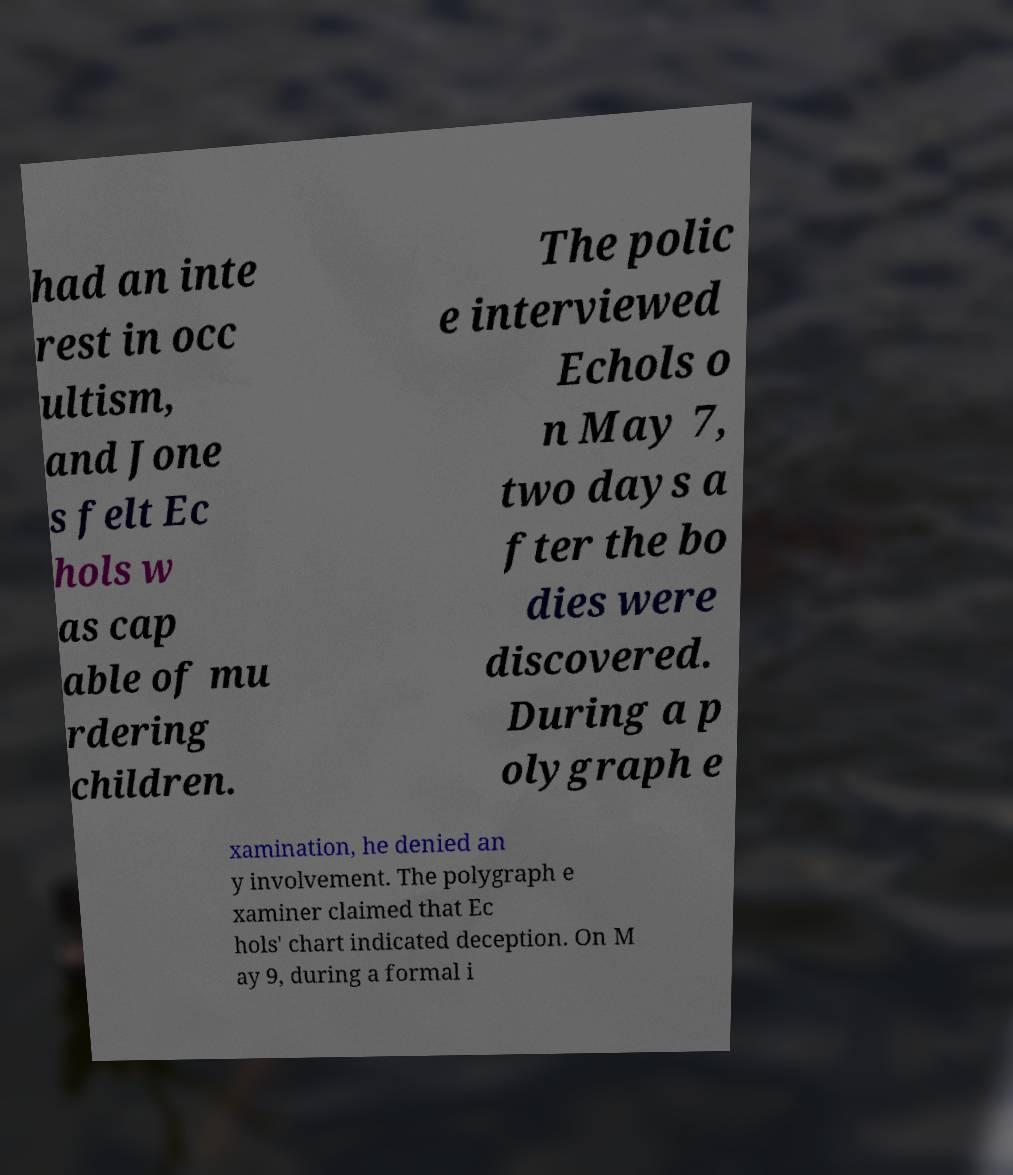Can you accurately transcribe the text from the provided image for me? had an inte rest in occ ultism, and Jone s felt Ec hols w as cap able of mu rdering children. The polic e interviewed Echols o n May 7, two days a fter the bo dies were discovered. During a p olygraph e xamination, he denied an y involvement. The polygraph e xaminer claimed that Ec hols' chart indicated deception. On M ay 9, during a formal i 